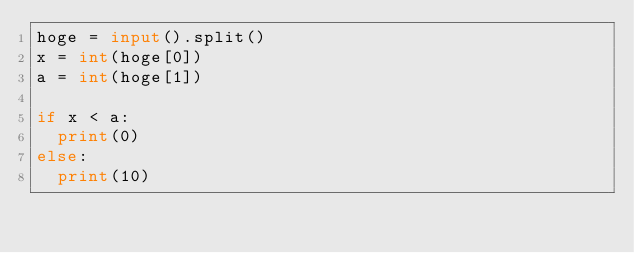Convert code to text. <code><loc_0><loc_0><loc_500><loc_500><_Python_>hoge = input().split()
x = int(hoge[0])
a = int(hoge[1])

if x < a:
  print(0)
else:
  print(10)</code> 